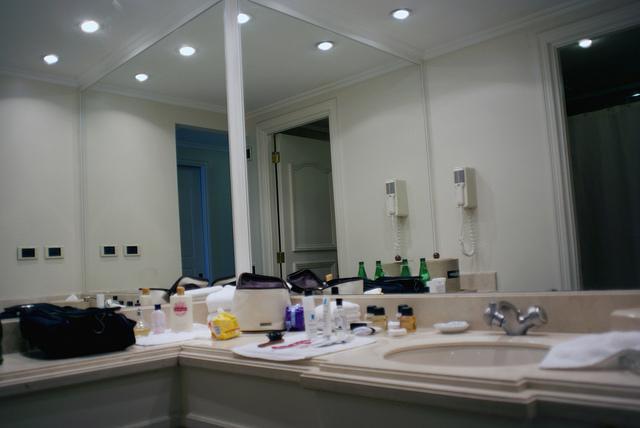How many sinks are on the counter?
Give a very brief answer. 1. How many green bottles are in this picture?
Give a very brief answer. 4. How many people are wearing a hat?
Give a very brief answer. 0. 